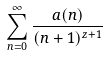Convert formula to latex. <formula><loc_0><loc_0><loc_500><loc_500>\sum _ { n = 0 } ^ { \infty } \frac { a ( n ) } { ( n + 1 ) ^ { z + 1 } }</formula> 